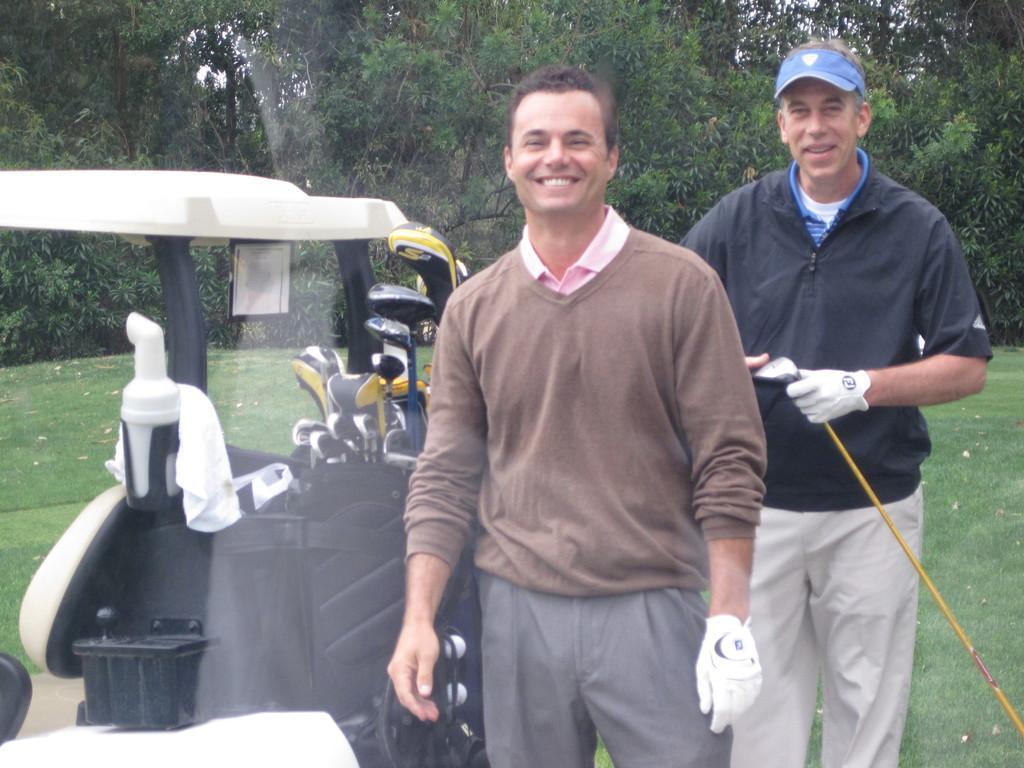Describe this image in one or two sentences. In this picture we can see two people,they are smiling,beside to them we can see a vehicle on the ground and in the background we can see trees. 